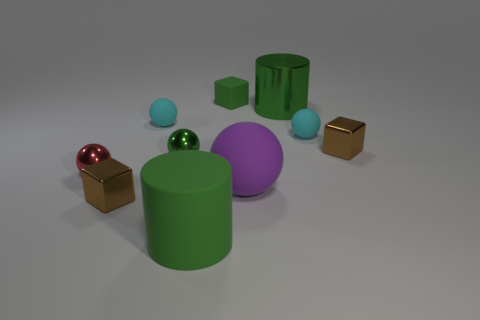Subtract all red spheres. How many spheres are left? 4 Subtract all big purple balls. How many balls are left? 4 Subtract all blue spheres. Subtract all purple cylinders. How many spheres are left? 5 Subtract all blocks. How many objects are left? 7 Add 7 small matte blocks. How many small matte blocks exist? 8 Subtract 1 red balls. How many objects are left? 9 Subtract all tiny blue blocks. Subtract all big green matte objects. How many objects are left? 9 Add 3 small green rubber things. How many small green rubber things are left? 4 